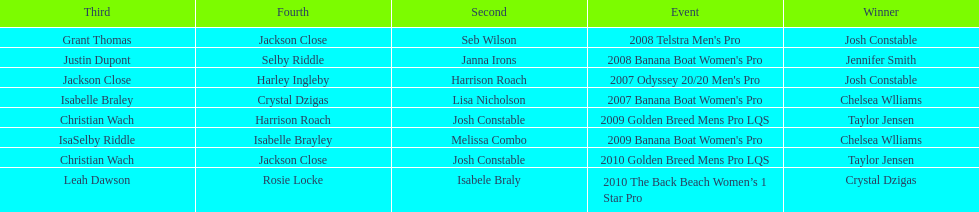Name each of the years that taylor jensen was winner. 2009, 2010. 